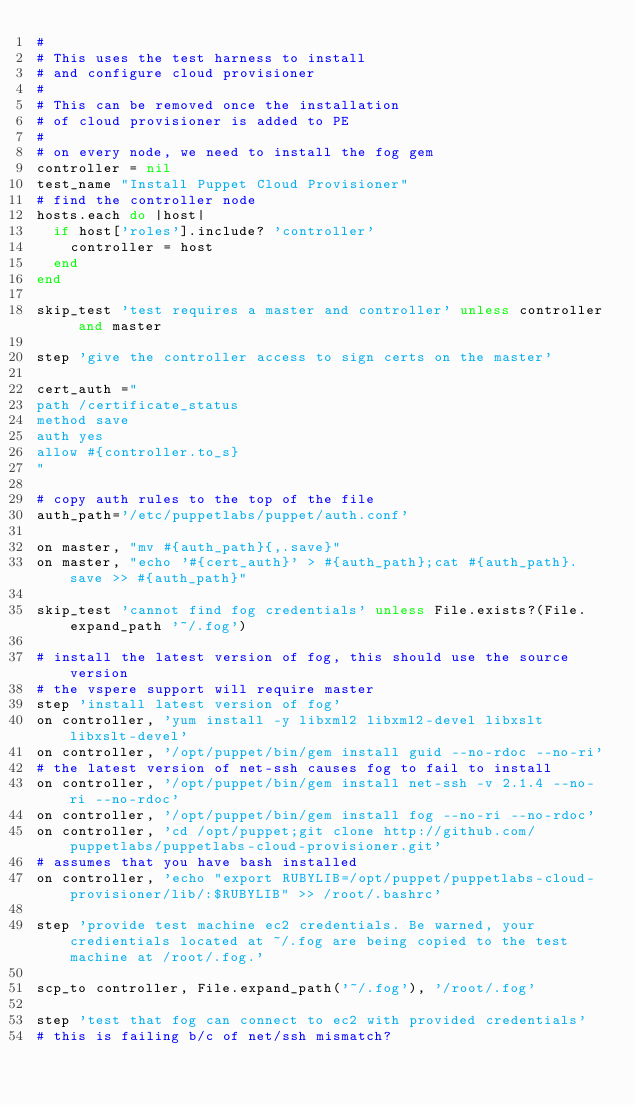Convert code to text. <code><loc_0><loc_0><loc_500><loc_500><_Ruby_>#
# This uses the test harness to install
# and configure cloud provisioner
#
# This can be removed once the installation
# of cloud provisioner is added to PE
#
# on every node, we need to install the fog gem
controller = nil
test_name "Install Puppet Cloud Provisioner"
# find the controller node
hosts.each do |host|
  if host['roles'].include? 'controller'
    controller = host
  end
end

skip_test 'test requires a master and controller' unless controller and master

step 'give the controller access to sign certs on the master'

cert_auth ="
path /certificate_status
method save
auth yes
allow #{controller.to_s}
"

# copy auth rules to the top of the file
auth_path='/etc/puppetlabs/puppet/auth.conf'

on master, "mv #{auth_path}{,.save}"
on master, "echo '#{cert_auth}' > #{auth_path};cat #{auth_path}.save >> #{auth_path}"

skip_test 'cannot find fog credentials' unless File.exists?(File.expand_path '~/.fog')

# install the latest version of fog, this should use the source version
# the vspere support will require master
step 'install latest version of fog'
on controller, 'yum install -y libxml2 libxml2-devel libxslt libxslt-devel'
on controller, '/opt/puppet/bin/gem install guid --no-rdoc --no-ri'
# the latest version of net-ssh causes fog to fail to install
on controller, '/opt/puppet/bin/gem install net-ssh -v 2.1.4 --no-ri --no-rdoc'
on controller, '/opt/puppet/bin/gem install fog --no-ri --no-rdoc'
on controller, 'cd /opt/puppet;git clone http://github.com/puppetlabs/puppetlabs-cloud-provisioner.git'
# assumes that you have bash installed
on controller, 'echo "export RUBYLIB=/opt/puppet/puppetlabs-cloud-provisioner/lib/:$RUBYLIB" >> /root/.bashrc'

step 'provide test machine ec2 credentials. Be warned, your credientials located at ~/.fog are being copied to the test machine at /root/.fog.'

scp_to controller, File.expand_path('~/.fog'), '/root/.fog'

step 'test that fog can connect to ec2 with provided credentials'
# this is failing b/c of net/ssh mismatch?</code> 